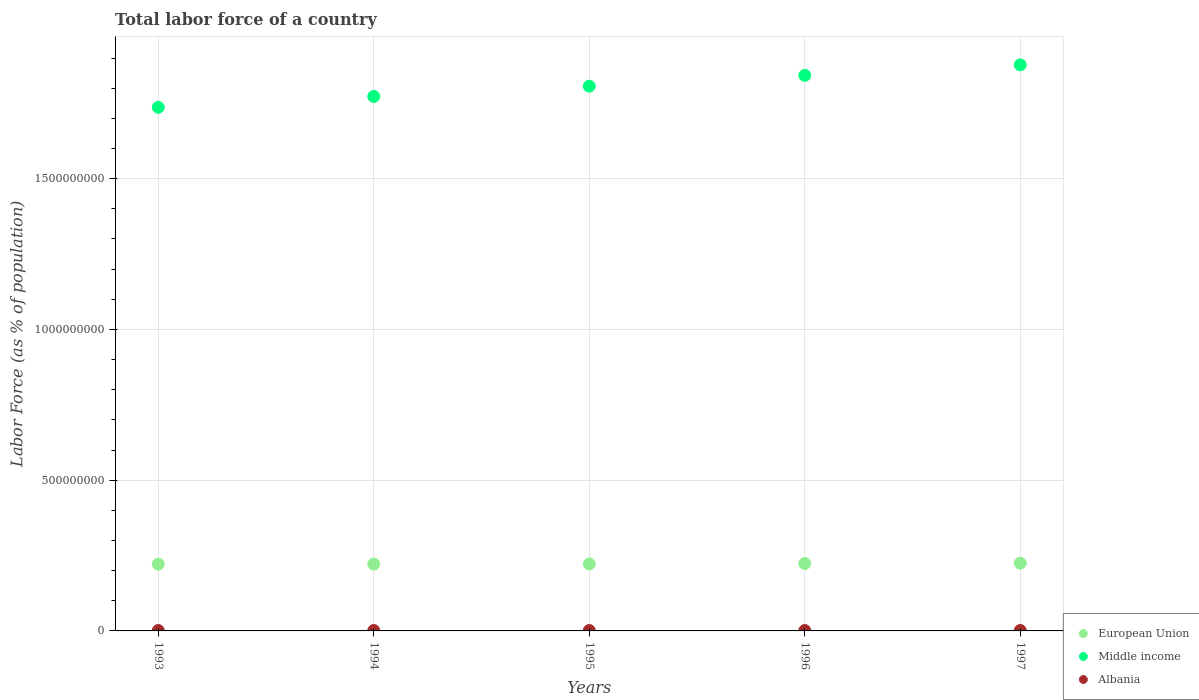Is the number of dotlines equal to the number of legend labels?
Ensure brevity in your answer.  Yes. What is the percentage of labor force in Middle income in 1997?
Your answer should be compact. 1.88e+09. Across all years, what is the maximum percentage of labor force in European Union?
Your answer should be very brief. 2.25e+08. Across all years, what is the minimum percentage of labor force in Albania?
Offer a very short reply. 1.37e+06. What is the total percentage of labor force in Middle income in the graph?
Offer a terse response. 9.04e+09. What is the difference between the percentage of labor force in Middle income in 1995 and that in 1997?
Offer a terse response. -7.06e+07. What is the difference between the percentage of labor force in Albania in 1995 and the percentage of labor force in Middle income in 1996?
Offer a terse response. -1.84e+09. What is the average percentage of labor force in European Union per year?
Give a very brief answer. 2.23e+08. In the year 1994, what is the difference between the percentage of labor force in European Union and percentage of labor force in Middle income?
Offer a terse response. -1.55e+09. In how many years, is the percentage of labor force in Middle income greater than 1100000000 %?
Your answer should be very brief. 5. What is the ratio of the percentage of labor force in Middle income in 1994 to that in 1997?
Offer a very short reply. 0.94. What is the difference between the highest and the second highest percentage of labor force in Middle income?
Keep it short and to the point. 3.48e+07. What is the difference between the highest and the lowest percentage of labor force in European Union?
Ensure brevity in your answer.  3.46e+06. Is the sum of the percentage of labor force in Middle income in 1993 and 1994 greater than the maximum percentage of labor force in European Union across all years?
Offer a terse response. Yes. Does the percentage of labor force in Middle income monotonically increase over the years?
Your answer should be very brief. Yes. Is the percentage of labor force in Albania strictly greater than the percentage of labor force in Middle income over the years?
Your answer should be very brief. No. How many years are there in the graph?
Provide a succinct answer. 5. What is the difference between two consecutive major ticks on the Y-axis?
Offer a terse response. 5.00e+08. Does the graph contain any zero values?
Provide a short and direct response. No. Where does the legend appear in the graph?
Provide a short and direct response. Bottom right. What is the title of the graph?
Your answer should be compact. Total labor force of a country. What is the label or title of the Y-axis?
Offer a very short reply. Labor Force (as % of population). What is the Labor Force (as % of population) of European Union in 1993?
Give a very brief answer. 2.21e+08. What is the Labor Force (as % of population) in Middle income in 1993?
Offer a terse response. 1.74e+09. What is the Labor Force (as % of population) of Albania in 1993?
Offer a terse response. 1.41e+06. What is the Labor Force (as % of population) in European Union in 1994?
Provide a short and direct response. 2.22e+08. What is the Labor Force (as % of population) in Middle income in 1994?
Your answer should be very brief. 1.77e+09. What is the Labor Force (as % of population) of Albania in 1994?
Make the answer very short. 1.39e+06. What is the Labor Force (as % of population) of European Union in 1995?
Give a very brief answer. 2.22e+08. What is the Labor Force (as % of population) in Middle income in 1995?
Make the answer very short. 1.81e+09. What is the Labor Force (as % of population) of Albania in 1995?
Give a very brief answer. 1.38e+06. What is the Labor Force (as % of population) in European Union in 1996?
Offer a terse response. 2.24e+08. What is the Labor Force (as % of population) of Middle income in 1996?
Make the answer very short. 1.84e+09. What is the Labor Force (as % of population) in Albania in 1996?
Provide a short and direct response. 1.37e+06. What is the Labor Force (as % of population) in European Union in 1997?
Make the answer very short. 2.25e+08. What is the Labor Force (as % of population) of Middle income in 1997?
Make the answer very short. 1.88e+09. What is the Labor Force (as % of population) of Albania in 1997?
Give a very brief answer. 1.37e+06. Across all years, what is the maximum Labor Force (as % of population) in European Union?
Offer a terse response. 2.25e+08. Across all years, what is the maximum Labor Force (as % of population) of Middle income?
Provide a short and direct response. 1.88e+09. Across all years, what is the maximum Labor Force (as % of population) in Albania?
Provide a short and direct response. 1.41e+06. Across all years, what is the minimum Labor Force (as % of population) of European Union?
Your response must be concise. 2.21e+08. Across all years, what is the minimum Labor Force (as % of population) of Middle income?
Offer a very short reply. 1.74e+09. Across all years, what is the minimum Labor Force (as % of population) of Albania?
Your response must be concise. 1.37e+06. What is the total Labor Force (as % of population) in European Union in the graph?
Ensure brevity in your answer.  1.11e+09. What is the total Labor Force (as % of population) of Middle income in the graph?
Give a very brief answer. 9.04e+09. What is the total Labor Force (as % of population) of Albania in the graph?
Your response must be concise. 6.92e+06. What is the difference between the Labor Force (as % of population) in European Union in 1993 and that in 1994?
Your response must be concise. -2.65e+05. What is the difference between the Labor Force (as % of population) of Middle income in 1993 and that in 1994?
Provide a succinct answer. -3.61e+07. What is the difference between the Labor Force (as % of population) of Albania in 1993 and that in 1994?
Offer a terse response. 1.12e+04. What is the difference between the Labor Force (as % of population) in European Union in 1993 and that in 1995?
Keep it short and to the point. -7.43e+05. What is the difference between the Labor Force (as % of population) in Middle income in 1993 and that in 1995?
Give a very brief answer. -7.02e+07. What is the difference between the Labor Force (as % of population) in Albania in 1993 and that in 1995?
Make the answer very short. 2.90e+04. What is the difference between the Labor Force (as % of population) of European Union in 1993 and that in 1996?
Give a very brief answer. -2.25e+06. What is the difference between the Labor Force (as % of population) in Middle income in 1993 and that in 1996?
Ensure brevity in your answer.  -1.06e+08. What is the difference between the Labor Force (as % of population) in Albania in 1993 and that in 1996?
Your answer should be very brief. 3.54e+04. What is the difference between the Labor Force (as % of population) in European Union in 1993 and that in 1997?
Your response must be concise. -3.46e+06. What is the difference between the Labor Force (as % of population) in Middle income in 1993 and that in 1997?
Your answer should be very brief. -1.41e+08. What is the difference between the Labor Force (as % of population) of Albania in 1993 and that in 1997?
Give a very brief answer. 3.25e+04. What is the difference between the Labor Force (as % of population) of European Union in 1994 and that in 1995?
Keep it short and to the point. -4.78e+05. What is the difference between the Labor Force (as % of population) in Middle income in 1994 and that in 1995?
Make the answer very short. -3.41e+07. What is the difference between the Labor Force (as % of population) of Albania in 1994 and that in 1995?
Offer a terse response. 1.78e+04. What is the difference between the Labor Force (as % of population) of European Union in 1994 and that in 1996?
Keep it short and to the point. -1.98e+06. What is the difference between the Labor Force (as % of population) of Middle income in 1994 and that in 1996?
Your answer should be compact. -6.99e+07. What is the difference between the Labor Force (as % of population) in Albania in 1994 and that in 1996?
Offer a very short reply. 2.42e+04. What is the difference between the Labor Force (as % of population) in European Union in 1994 and that in 1997?
Ensure brevity in your answer.  -3.19e+06. What is the difference between the Labor Force (as % of population) in Middle income in 1994 and that in 1997?
Provide a short and direct response. -1.05e+08. What is the difference between the Labor Force (as % of population) of Albania in 1994 and that in 1997?
Your answer should be compact. 2.13e+04. What is the difference between the Labor Force (as % of population) of European Union in 1995 and that in 1996?
Provide a succinct answer. -1.50e+06. What is the difference between the Labor Force (as % of population) in Middle income in 1995 and that in 1996?
Offer a very short reply. -3.58e+07. What is the difference between the Labor Force (as % of population) of Albania in 1995 and that in 1996?
Give a very brief answer. 6427. What is the difference between the Labor Force (as % of population) in European Union in 1995 and that in 1997?
Give a very brief answer. -2.71e+06. What is the difference between the Labor Force (as % of population) in Middle income in 1995 and that in 1997?
Provide a succinct answer. -7.06e+07. What is the difference between the Labor Force (as % of population) of Albania in 1995 and that in 1997?
Keep it short and to the point. 3514. What is the difference between the Labor Force (as % of population) in European Union in 1996 and that in 1997?
Your response must be concise. -1.21e+06. What is the difference between the Labor Force (as % of population) in Middle income in 1996 and that in 1997?
Offer a very short reply. -3.48e+07. What is the difference between the Labor Force (as % of population) of Albania in 1996 and that in 1997?
Offer a very short reply. -2913. What is the difference between the Labor Force (as % of population) in European Union in 1993 and the Labor Force (as % of population) in Middle income in 1994?
Ensure brevity in your answer.  -1.55e+09. What is the difference between the Labor Force (as % of population) of European Union in 1993 and the Labor Force (as % of population) of Albania in 1994?
Ensure brevity in your answer.  2.20e+08. What is the difference between the Labor Force (as % of population) of Middle income in 1993 and the Labor Force (as % of population) of Albania in 1994?
Offer a very short reply. 1.74e+09. What is the difference between the Labor Force (as % of population) in European Union in 1993 and the Labor Force (as % of population) in Middle income in 1995?
Keep it short and to the point. -1.59e+09. What is the difference between the Labor Force (as % of population) of European Union in 1993 and the Labor Force (as % of population) of Albania in 1995?
Give a very brief answer. 2.20e+08. What is the difference between the Labor Force (as % of population) in Middle income in 1993 and the Labor Force (as % of population) in Albania in 1995?
Give a very brief answer. 1.74e+09. What is the difference between the Labor Force (as % of population) in European Union in 1993 and the Labor Force (as % of population) in Middle income in 1996?
Offer a very short reply. -1.62e+09. What is the difference between the Labor Force (as % of population) of European Union in 1993 and the Labor Force (as % of population) of Albania in 1996?
Your response must be concise. 2.20e+08. What is the difference between the Labor Force (as % of population) of Middle income in 1993 and the Labor Force (as % of population) of Albania in 1996?
Offer a terse response. 1.74e+09. What is the difference between the Labor Force (as % of population) of European Union in 1993 and the Labor Force (as % of population) of Middle income in 1997?
Your answer should be compact. -1.66e+09. What is the difference between the Labor Force (as % of population) of European Union in 1993 and the Labor Force (as % of population) of Albania in 1997?
Provide a succinct answer. 2.20e+08. What is the difference between the Labor Force (as % of population) in Middle income in 1993 and the Labor Force (as % of population) in Albania in 1997?
Make the answer very short. 1.74e+09. What is the difference between the Labor Force (as % of population) in European Union in 1994 and the Labor Force (as % of population) in Middle income in 1995?
Offer a very short reply. -1.59e+09. What is the difference between the Labor Force (as % of population) of European Union in 1994 and the Labor Force (as % of population) of Albania in 1995?
Provide a succinct answer. 2.20e+08. What is the difference between the Labor Force (as % of population) in Middle income in 1994 and the Labor Force (as % of population) in Albania in 1995?
Provide a short and direct response. 1.77e+09. What is the difference between the Labor Force (as % of population) in European Union in 1994 and the Labor Force (as % of population) in Middle income in 1996?
Provide a succinct answer. -1.62e+09. What is the difference between the Labor Force (as % of population) in European Union in 1994 and the Labor Force (as % of population) in Albania in 1996?
Give a very brief answer. 2.20e+08. What is the difference between the Labor Force (as % of population) of Middle income in 1994 and the Labor Force (as % of population) of Albania in 1996?
Keep it short and to the point. 1.77e+09. What is the difference between the Labor Force (as % of population) of European Union in 1994 and the Labor Force (as % of population) of Middle income in 1997?
Your answer should be very brief. -1.66e+09. What is the difference between the Labor Force (as % of population) of European Union in 1994 and the Labor Force (as % of population) of Albania in 1997?
Offer a terse response. 2.20e+08. What is the difference between the Labor Force (as % of population) of Middle income in 1994 and the Labor Force (as % of population) of Albania in 1997?
Your answer should be compact. 1.77e+09. What is the difference between the Labor Force (as % of population) of European Union in 1995 and the Labor Force (as % of population) of Middle income in 1996?
Offer a terse response. -1.62e+09. What is the difference between the Labor Force (as % of population) in European Union in 1995 and the Labor Force (as % of population) in Albania in 1996?
Make the answer very short. 2.21e+08. What is the difference between the Labor Force (as % of population) of Middle income in 1995 and the Labor Force (as % of population) of Albania in 1996?
Your answer should be compact. 1.81e+09. What is the difference between the Labor Force (as % of population) in European Union in 1995 and the Labor Force (as % of population) in Middle income in 1997?
Provide a succinct answer. -1.66e+09. What is the difference between the Labor Force (as % of population) of European Union in 1995 and the Labor Force (as % of population) of Albania in 1997?
Ensure brevity in your answer.  2.21e+08. What is the difference between the Labor Force (as % of population) in Middle income in 1995 and the Labor Force (as % of population) in Albania in 1997?
Your response must be concise. 1.81e+09. What is the difference between the Labor Force (as % of population) of European Union in 1996 and the Labor Force (as % of population) of Middle income in 1997?
Offer a terse response. -1.65e+09. What is the difference between the Labor Force (as % of population) of European Union in 1996 and the Labor Force (as % of population) of Albania in 1997?
Your answer should be very brief. 2.22e+08. What is the difference between the Labor Force (as % of population) of Middle income in 1996 and the Labor Force (as % of population) of Albania in 1997?
Offer a very short reply. 1.84e+09. What is the average Labor Force (as % of population) of European Union per year?
Your answer should be very brief. 2.23e+08. What is the average Labor Force (as % of population) of Middle income per year?
Provide a succinct answer. 1.81e+09. What is the average Labor Force (as % of population) in Albania per year?
Your answer should be compact. 1.38e+06. In the year 1993, what is the difference between the Labor Force (as % of population) of European Union and Labor Force (as % of population) of Middle income?
Offer a very short reply. -1.52e+09. In the year 1993, what is the difference between the Labor Force (as % of population) in European Union and Labor Force (as % of population) in Albania?
Ensure brevity in your answer.  2.20e+08. In the year 1993, what is the difference between the Labor Force (as % of population) in Middle income and Labor Force (as % of population) in Albania?
Ensure brevity in your answer.  1.74e+09. In the year 1994, what is the difference between the Labor Force (as % of population) in European Union and Labor Force (as % of population) in Middle income?
Your answer should be compact. -1.55e+09. In the year 1994, what is the difference between the Labor Force (as % of population) of European Union and Labor Force (as % of population) of Albania?
Your answer should be compact. 2.20e+08. In the year 1994, what is the difference between the Labor Force (as % of population) in Middle income and Labor Force (as % of population) in Albania?
Your response must be concise. 1.77e+09. In the year 1995, what is the difference between the Labor Force (as % of population) of European Union and Labor Force (as % of population) of Middle income?
Offer a terse response. -1.58e+09. In the year 1995, what is the difference between the Labor Force (as % of population) in European Union and Labor Force (as % of population) in Albania?
Your response must be concise. 2.21e+08. In the year 1995, what is the difference between the Labor Force (as % of population) of Middle income and Labor Force (as % of population) of Albania?
Your answer should be very brief. 1.81e+09. In the year 1996, what is the difference between the Labor Force (as % of population) of European Union and Labor Force (as % of population) of Middle income?
Give a very brief answer. -1.62e+09. In the year 1996, what is the difference between the Labor Force (as % of population) in European Union and Labor Force (as % of population) in Albania?
Provide a succinct answer. 2.22e+08. In the year 1996, what is the difference between the Labor Force (as % of population) of Middle income and Labor Force (as % of population) of Albania?
Offer a terse response. 1.84e+09. In the year 1997, what is the difference between the Labor Force (as % of population) in European Union and Labor Force (as % of population) in Middle income?
Make the answer very short. -1.65e+09. In the year 1997, what is the difference between the Labor Force (as % of population) in European Union and Labor Force (as % of population) in Albania?
Offer a very short reply. 2.23e+08. In the year 1997, what is the difference between the Labor Force (as % of population) of Middle income and Labor Force (as % of population) of Albania?
Your answer should be very brief. 1.88e+09. What is the ratio of the Labor Force (as % of population) of Middle income in 1993 to that in 1994?
Your response must be concise. 0.98. What is the ratio of the Labor Force (as % of population) in Albania in 1993 to that in 1994?
Keep it short and to the point. 1.01. What is the ratio of the Labor Force (as % of population) of European Union in 1993 to that in 1995?
Offer a very short reply. 1. What is the ratio of the Labor Force (as % of population) in Middle income in 1993 to that in 1995?
Provide a succinct answer. 0.96. What is the ratio of the Labor Force (as % of population) of European Union in 1993 to that in 1996?
Make the answer very short. 0.99. What is the ratio of the Labor Force (as % of population) in Middle income in 1993 to that in 1996?
Your answer should be very brief. 0.94. What is the ratio of the Labor Force (as % of population) of Albania in 1993 to that in 1996?
Offer a very short reply. 1.03. What is the ratio of the Labor Force (as % of population) in European Union in 1993 to that in 1997?
Keep it short and to the point. 0.98. What is the ratio of the Labor Force (as % of population) in Middle income in 1993 to that in 1997?
Provide a short and direct response. 0.93. What is the ratio of the Labor Force (as % of population) in Albania in 1993 to that in 1997?
Provide a short and direct response. 1.02. What is the ratio of the Labor Force (as % of population) of Middle income in 1994 to that in 1995?
Provide a succinct answer. 0.98. What is the ratio of the Labor Force (as % of population) in Albania in 1994 to that in 1995?
Your response must be concise. 1.01. What is the ratio of the Labor Force (as % of population) of Middle income in 1994 to that in 1996?
Your answer should be very brief. 0.96. What is the ratio of the Labor Force (as % of population) in Albania in 1994 to that in 1996?
Offer a terse response. 1.02. What is the ratio of the Labor Force (as % of population) in European Union in 1994 to that in 1997?
Keep it short and to the point. 0.99. What is the ratio of the Labor Force (as % of population) of Middle income in 1994 to that in 1997?
Provide a succinct answer. 0.94. What is the ratio of the Labor Force (as % of population) of Albania in 1994 to that in 1997?
Ensure brevity in your answer.  1.02. What is the ratio of the Labor Force (as % of population) of European Union in 1995 to that in 1996?
Provide a succinct answer. 0.99. What is the ratio of the Labor Force (as % of population) of Middle income in 1995 to that in 1996?
Provide a succinct answer. 0.98. What is the ratio of the Labor Force (as % of population) of European Union in 1995 to that in 1997?
Offer a terse response. 0.99. What is the ratio of the Labor Force (as % of population) of Middle income in 1995 to that in 1997?
Your response must be concise. 0.96. What is the ratio of the Labor Force (as % of population) in European Union in 1996 to that in 1997?
Provide a succinct answer. 0.99. What is the ratio of the Labor Force (as % of population) in Middle income in 1996 to that in 1997?
Give a very brief answer. 0.98. What is the difference between the highest and the second highest Labor Force (as % of population) of European Union?
Make the answer very short. 1.21e+06. What is the difference between the highest and the second highest Labor Force (as % of population) in Middle income?
Your answer should be very brief. 3.48e+07. What is the difference between the highest and the second highest Labor Force (as % of population) of Albania?
Provide a succinct answer. 1.12e+04. What is the difference between the highest and the lowest Labor Force (as % of population) of European Union?
Ensure brevity in your answer.  3.46e+06. What is the difference between the highest and the lowest Labor Force (as % of population) of Middle income?
Provide a short and direct response. 1.41e+08. What is the difference between the highest and the lowest Labor Force (as % of population) of Albania?
Offer a terse response. 3.54e+04. 